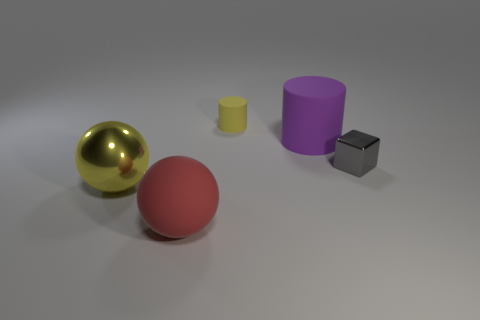Add 4 gray things. How many objects exist? 9 Subtract all cylinders. How many objects are left? 3 Subtract 1 yellow cylinders. How many objects are left? 4 Subtract all large purple things. Subtract all large purple rubber cylinders. How many objects are left? 3 Add 3 gray blocks. How many gray blocks are left? 4 Add 3 purple metal cylinders. How many purple metal cylinders exist? 3 